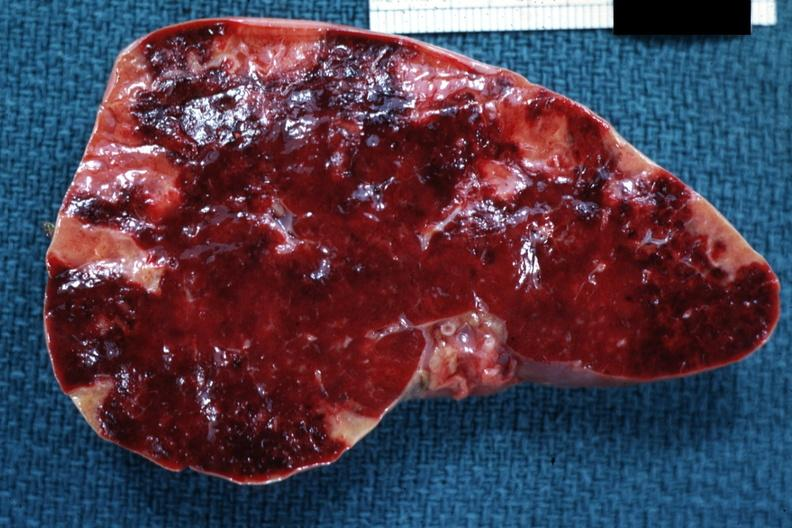what is present?
Answer the question using a single word or phrase. Hematologic 